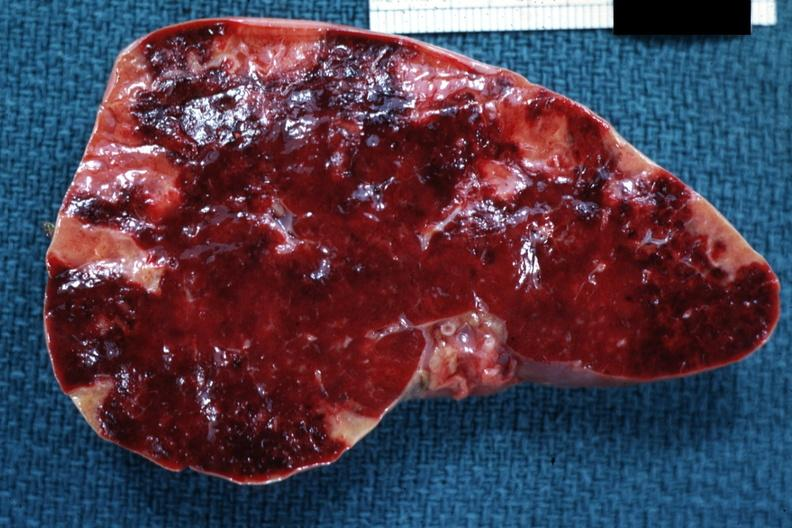what is present?
Answer the question using a single word or phrase. Hematologic 